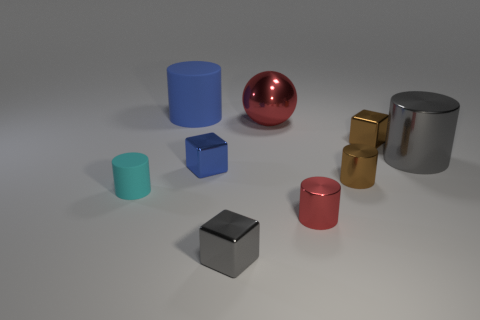Subtract 2 cylinders. How many cylinders are left? 3 Subtract all gray cylinders. How many cylinders are left? 4 Subtract all gray metal cylinders. How many cylinders are left? 4 Add 1 cylinders. How many objects exist? 10 Subtract all yellow cylinders. Subtract all purple cubes. How many cylinders are left? 5 Subtract all cylinders. How many objects are left? 4 Subtract 1 red spheres. How many objects are left? 8 Subtract all brown cylinders. Subtract all large blue rubber cylinders. How many objects are left? 7 Add 7 big metallic objects. How many big metallic objects are left? 9 Add 3 large gray metal cylinders. How many large gray metal cylinders exist? 4 